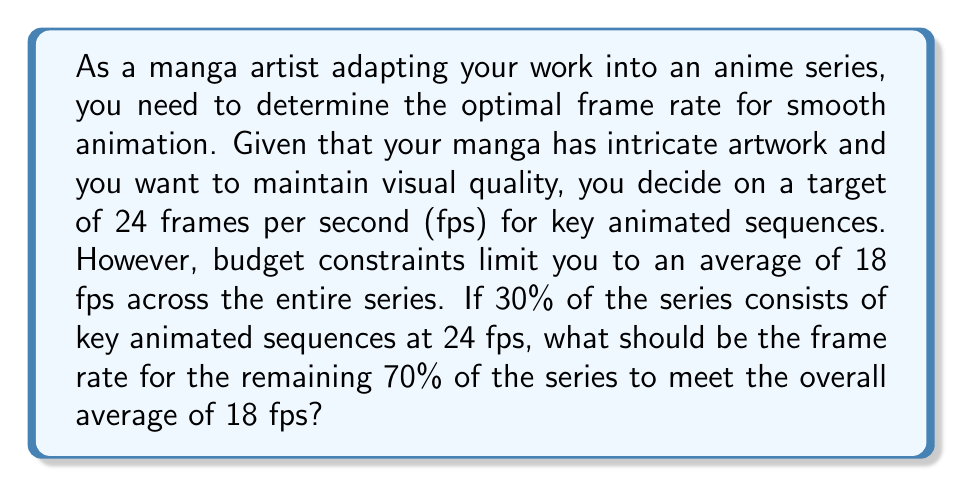Help me with this question. Let's approach this step-by-step:

1) Let $x$ be the frame rate for the non-key sequences.

2) We know that 30% of the series is at 24 fps and 70% is at $x$ fps.

3) The weighted average of these should equal 18 fps:

   $$(0.3 \times 24) + (0.7 \times x) = 18$$

4) Let's solve this equation:

   $$7.2 + 0.7x = 18$$

5) Subtract 7.2 from both sides:

   $$0.7x = 10.8$$

6) Divide both sides by 0.7:

   $$x = \frac{10.8}{0.7} = 15.4285...$$

7) Rounding to two decimal places:

   $$x \approx 15.43$$

Therefore, the non-key sequences should be animated at approximately 15.43 fps to achieve an overall average of 18 fps for the entire series.
Answer: 15.43 fps 